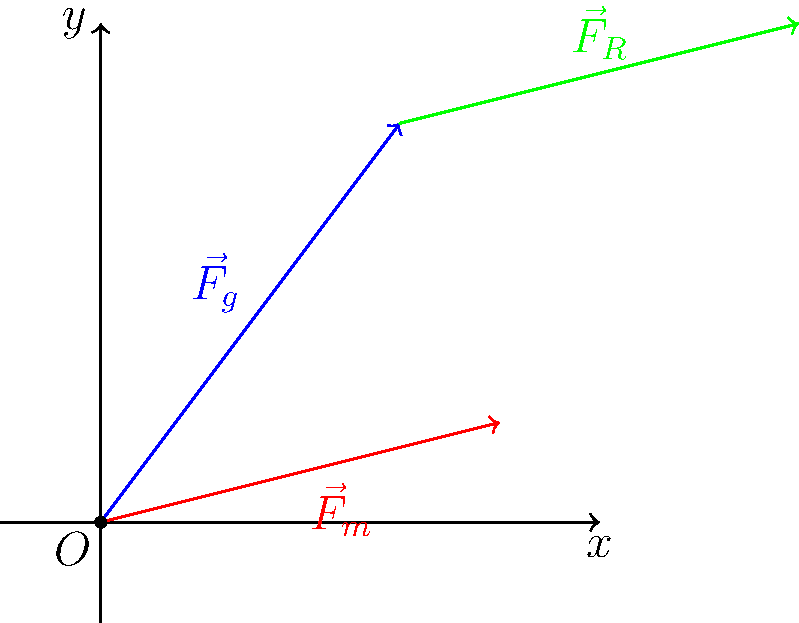During a jump shot, a handball player experiences three main forces: gravity ($\vec{F}_g$), muscle force ($\vec{F}_m$), and air resistance ($\vec{F}_R$). Given that $\vec{F}_g = 3\hat{i} + 4\hat{j}$, $\vec{F}_m = 4\hat{i} + \hat{j}$, and $\vec{F}_R = 4\hat{i} + \hat{j}$, calculate the magnitude of the net force acting on the player. To solve this problem, we'll follow these steps:

1) First, we need to find the net force by adding all the force vectors:
   $\vec{F}_{net} = \vec{F}_g + \vec{F}_m + \vec{F}_R$

2) Let's add the vectors component by component:
   $\vec{F}_{net} = (3\hat{i} + 4\hat{j}) + (4\hat{i} + \hat{j}) + (4\hat{i} + \hat{j})$

3) Combining like terms:
   $\vec{F}_{net} = (3 + 4 + 4)\hat{i} + (4 + 1 + 1)\hat{j}$
   $\vec{F}_{net} = 11\hat{i} + 6\hat{j}$

4) Now that we have the net force vector, we can calculate its magnitude using the Pythagorean theorem:
   $|\vec{F}_{net}| = \sqrt{(11)^2 + (6)^2}$

5) Simplify:
   $|\vec{F}_{net}| = \sqrt{121 + 36} = \sqrt{157}$

Therefore, the magnitude of the net force acting on the player is $\sqrt{157}$ N.
Answer: $\sqrt{157}$ N 